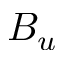Convert formula to latex. <formula><loc_0><loc_0><loc_500><loc_500>B _ { u }</formula> 